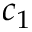Convert formula to latex. <formula><loc_0><loc_0><loc_500><loc_500>c _ { 1 }</formula> 